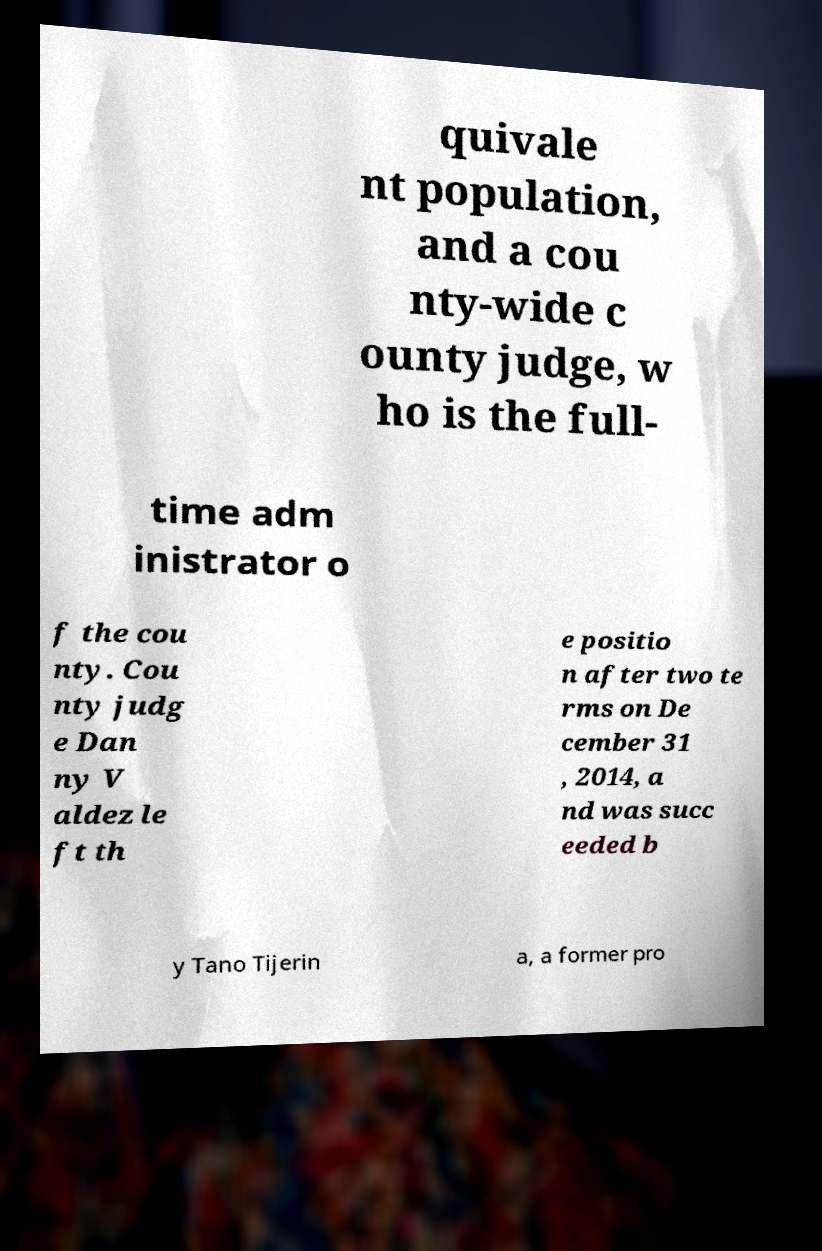Can you read and provide the text displayed in the image?This photo seems to have some interesting text. Can you extract and type it out for me? quivale nt population, and a cou nty-wide c ounty judge, w ho is the full- time adm inistrator o f the cou nty. Cou nty judg e Dan ny V aldez le ft th e positio n after two te rms on De cember 31 , 2014, a nd was succ eeded b y Tano Tijerin a, a former pro 